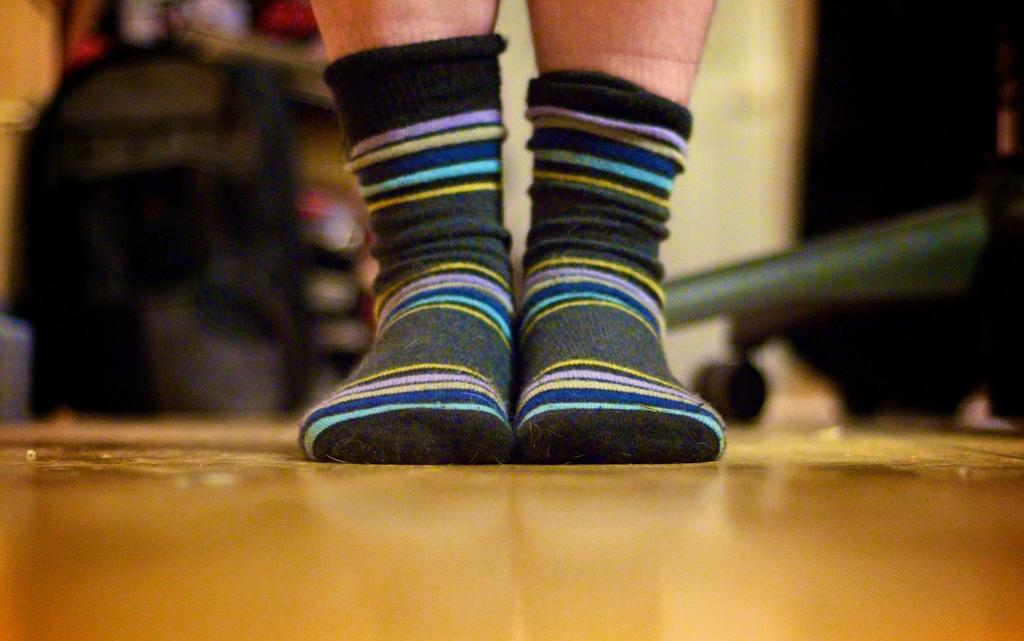Who or what is present in the image? There is a person in the image. What is the person wearing on their feet? The person is wearing socks. What surface is the person standing on? The person is standing on the floor. Can you describe any other objects or elements in the background of the image? There are other objects in the background of the image, but their specific details are not mentioned in the provided facts. What type of insurance policy does the person have in the image? There is no information about insurance policies in the image, as the provided facts only mention the person, their socks, and the floor. 